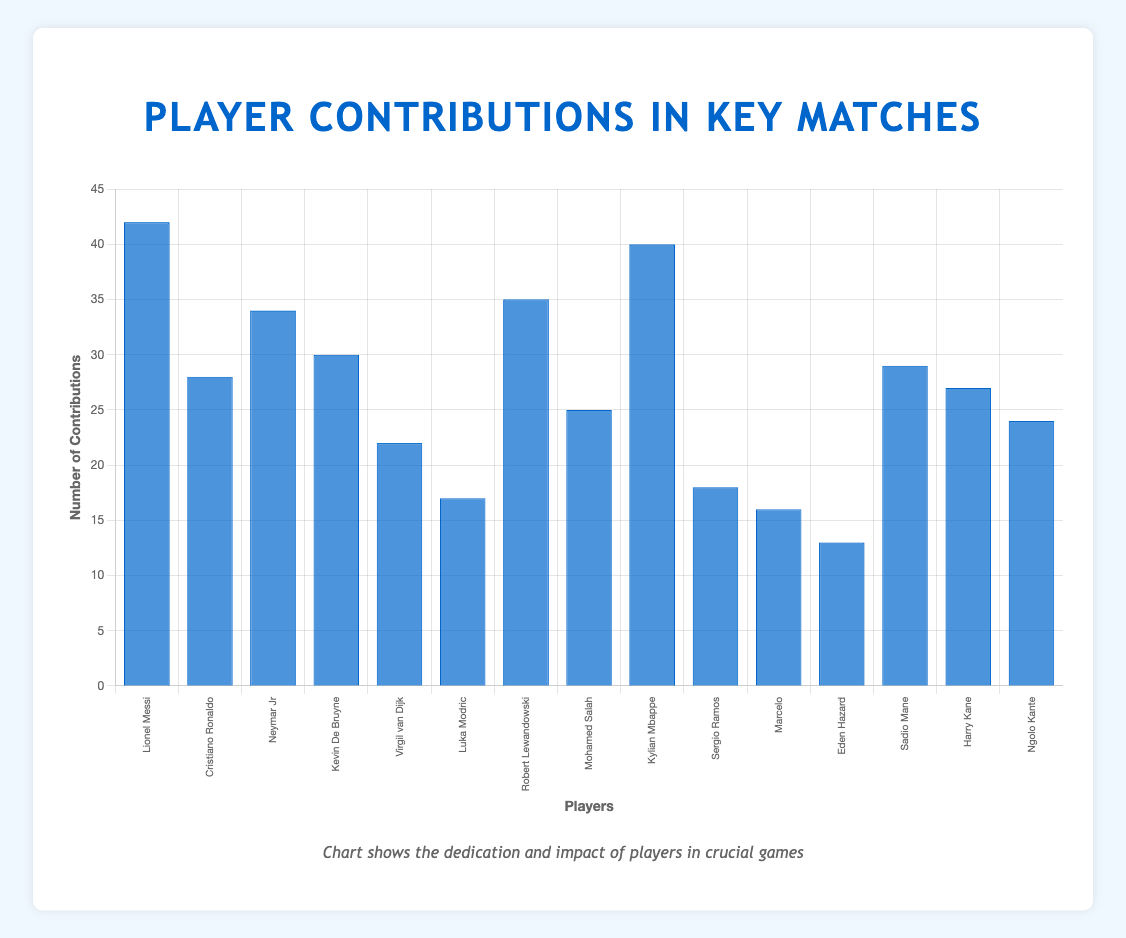What's the player with the highest number of contributions? By looking at the height of the bars, the highest bar corresponds to Lionel Messi with 42 contributions.
Answer: Lionel Messi Which player has more contributions: Mohamed Salah or Luka Modric? Compare the two bars representing Mohamed Salah (25 contributions) and Luka Modric (17 contributions). Mohamed Salah has more contributions.
Answer: Mohamed Salah What's the total number of contributions from players with high effort levels? Sum the contributions of players with high effort levels: Lionel Messi (42) + Neymar Jr (34) + Kevin De Bruyne (30) + Virgil van Dijk (22) + Robert Lewandowski (35) + Kylian Mbappe (40) + Sadio Mane (29) + Harry Kane (27) + Ngolo Kante (24). The total is 283.
Answer: 283 How many players have made more than 30 contributions in key matches? Identify and count the bars taller than 30: Lionel Messi (42), Neymar Jr (34), Robert Lewandowski (35), Kylian Mbappe (40). Four players made more than 30 contributions.
Answer: 4 Who has the lowest number of contributions among players with medium effort levels? Compare the bars representing medium effort levels and find the shortest one, which is Eden Hazard with 13 contributions.
Answer: Eden Hazard Compare the contributions of Cristiano Ronaldo and Sadio Mane. Who contributed more? Cristiano Ronaldo made 28 contributions while Sadio Mane made 29 contributions. Therefore, Sadio Mane contributed more.
Answer: Sadio Mane What's the average contribution of all players in key matches? Sum all contributions and divide by the number of players. Total contributions are (42 + 28 + 34 + 30 + 22 + 17 + 35 + 25 + 40 + 18 + 16 + 13 + 29 + 27 + 24) = 380. The number of players is 15. The average contribution is 380 / 15 ≈ 25.33.
Answer: 25.33 What's the difference in contributions between Kylian Mbappe and Virgil van Dijk? Kylian Mbappe made 40 contributions, while Virgil van Dijk made 22. The difference is 40 - 22 = 18.
Answer: 18 